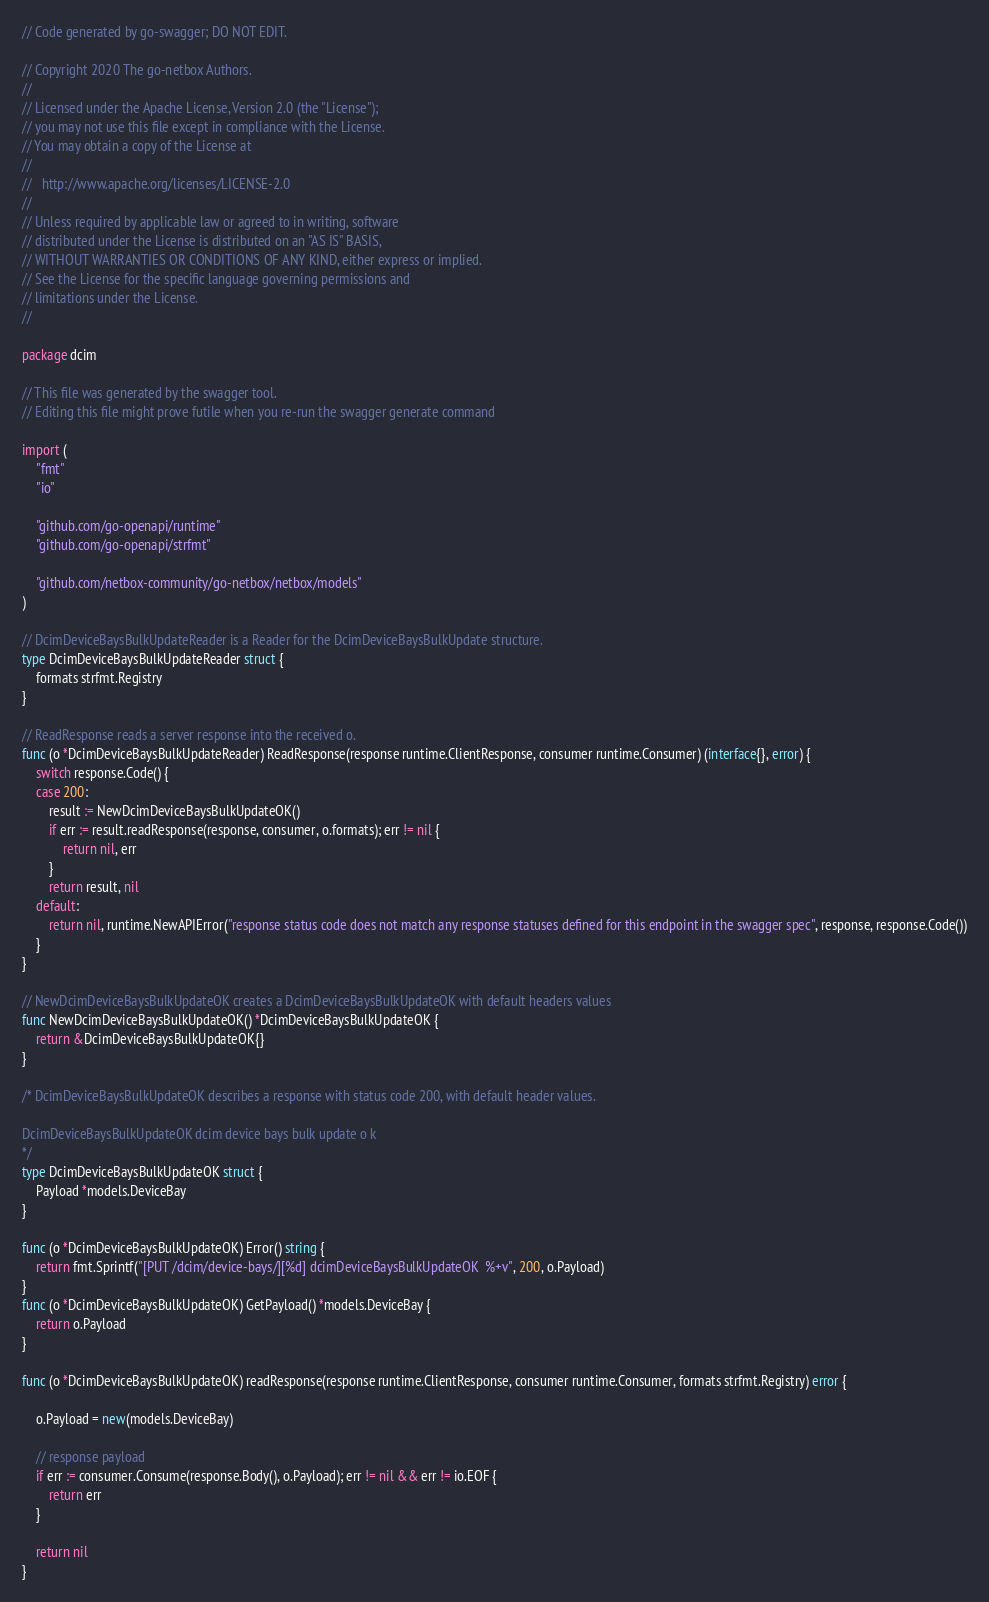Convert code to text. <code><loc_0><loc_0><loc_500><loc_500><_Go_>// Code generated by go-swagger; DO NOT EDIT.

// Copyright 2020 The go-netbox Authors.
//
// Licensed under the Apache License, Version 2.0 (the "License");
// you may not use this file except in compliance with the License.
// You may obtain a copy of the License at
//
//   http://www.apache.org/licenses/LICENSE-2.0
//
// Unless required by applicable law or agreed to in writing, software
// distributed under the License is distributed on an "AS IS" BASIS,
// WITHOUT WARRANTIES OR CONDITIONS OF ANY KIND, either express or implied.
// See the License for the specific language governing permissions and
// limitations under the License.
//

package dcim

// This file was generated by the swagger tool.
// Editing this file might prove futile when you re-run the swagger generate command

import (
	"fmt"
	"io"

	"github.com/go-openapi/runtime"
	"github.com/go-openapi/strfmt"

	"github.com/netbox-community/go-netbox/netbox/models"
)

// DcimDeviceBaysBulkUpdateReader is a Reader for the DcimDeviceBaysBulkUpdate structure.
type DcimDeviceBaysBulkUpdateReader struct {
	formats strfmt.Registry
}

// ReadResponse reads a server response into the received o.
func (o *DcimDeviceBaysBulkUpdateReader) ReadResponse(response runtime.ClientResponse, consumer runtime.Consumer) (interface{}, error) {
	switch response.Code() {
	case 200:
		result := NewDcimDeviceBaysBulkUpdateOK()
		if err := result.readResponse(response, consumer, o.formats); err != nil {
			return nil, err
		}
		return result, nil
	default:
		return nil, runtime.NewAPIError("response status code does not match any response statuses defined for this endpoint in the swagger spec", response, response.Code())
	}
}

// NewDcimDeviceBaysBulkUpdateOK creates a DcimDeviceBaysBulkUpdateOK with default headers values
func NewDcimDeviceBaysBulkUpdateOK() *DcimDeviceBaysBulkUpdateOK {
	return &DcimDeviceBaysBulkUpdateOK{}
}

/* DcimDeviceBaysBulkUpdateOK describes a response with status code 200, with default header values.

DcimDeviceBaysBulkUpdateOK dcim device bays bulk update o k
*/
type DcimDeviceBaysBulkUpdateOK struct {
	Payload *models.DeviceBay
}

func (o *DcimDeviceBaysBulkUpdateOK) Error() string {
	return fmt.Sprintf("[PUT /dcim/device-bays/][%d] dcimDeviceBaysBulkUpdateOK  %+v", 200, o.Payload)
}
func (o *DcimDeviceBaysBulkUpdateOK) GetPayload() *models.DeviceBay {
	return o.Payload
}

func (o *DcimDeviceBaysBulkUpdateOK) readResponse(response runtime.ClientResponse, consumer runtime.Consumer, formats strfmt.Registry) error {

	o.Payload = new(models.DeviceBay)

	// response payload
	if err := consumer.Consume(response.Body(), o.Payload); err != nil && err != io.EOF {
		return err
	}

	return nil
}
</code> 